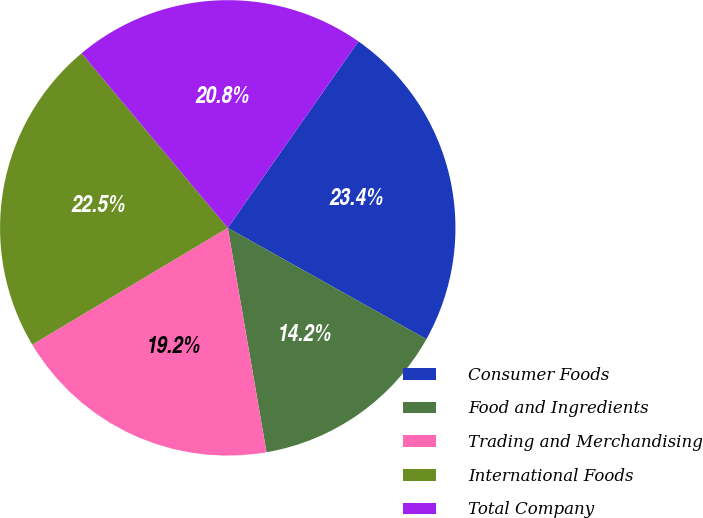Convert chart. <chart><loc_0><loc_0><loc_500><loc_500><pie_chart><fcel>Consumer Foods<fcel>Food and Ingredients<fcel>Trading and Merchandising<fcel>International Foods<fcel>Total Company<nl><fcel>23.4%<fcel>14.15%<fcel>19.15%<fcel>22.48%<fcel>20.82%<nl></chart> 